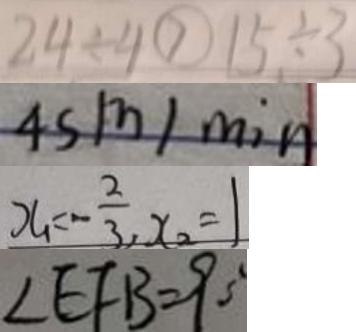Convert formula to latex. <formula><loc_0><loc_0><loc_500><loc_500>2 4 \div 4 > 1 5 \div 3 
 4 s m / \min 
 x _ { 1 } = - \frac { 2 } { 3 } , x _ { 2 } = 1 
 \angle E F B = 9 0 ^ { \circ }</formula> 